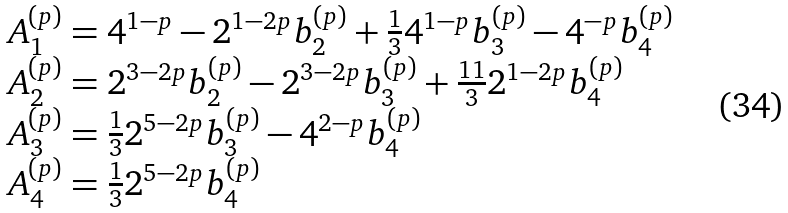Convert formula to latex. <formula><loc_0><loc_0><loc_500><loc_500>\begin{array} { l } { A _ { 1 } ^ { ( p ) } = 4 ^ { 1 - p } - 2 ^ { 1 - 2 p } b _ { 2 } ^ { ( p ) } + { \frac { 1 } { 3 } } 4 ^ { 1 - p } b _ { 3 } ^ { ( p ) } - 4 ^ { - p } b _ { 4 } ^ { ( p ) } } \\ { A _ { 2 } ^ { ( p ) } = 2 ^ { 3 - 2 p } b _ { 2 } ^ { ( p ) } - 2 ^ { 3 - 2 p } b _ { 3 } ^ { ( p ) } + { \frac { 1 1 } { 3 } } 2 ^ { 1 - 2 p } b _ { 4 } ^ { ( p ) } } \\ { A _ { 3 } ^ { ( p ) } = { \frac { 1 } { 3 } } 2 ^ { 5 - 2 p } b _ { 3 } ^ { ( p ) } - 4 ^ { 2 - p } b _ { 4 } ^ { ( p ) } } \\ { A _ { 4 } ^ { ( p ) } = { \frac { 1 } { 3 } } 2 ^ { 5 - 2 p } b _ { 4 } ^ { ( p ) } } \end{array}</formula> 